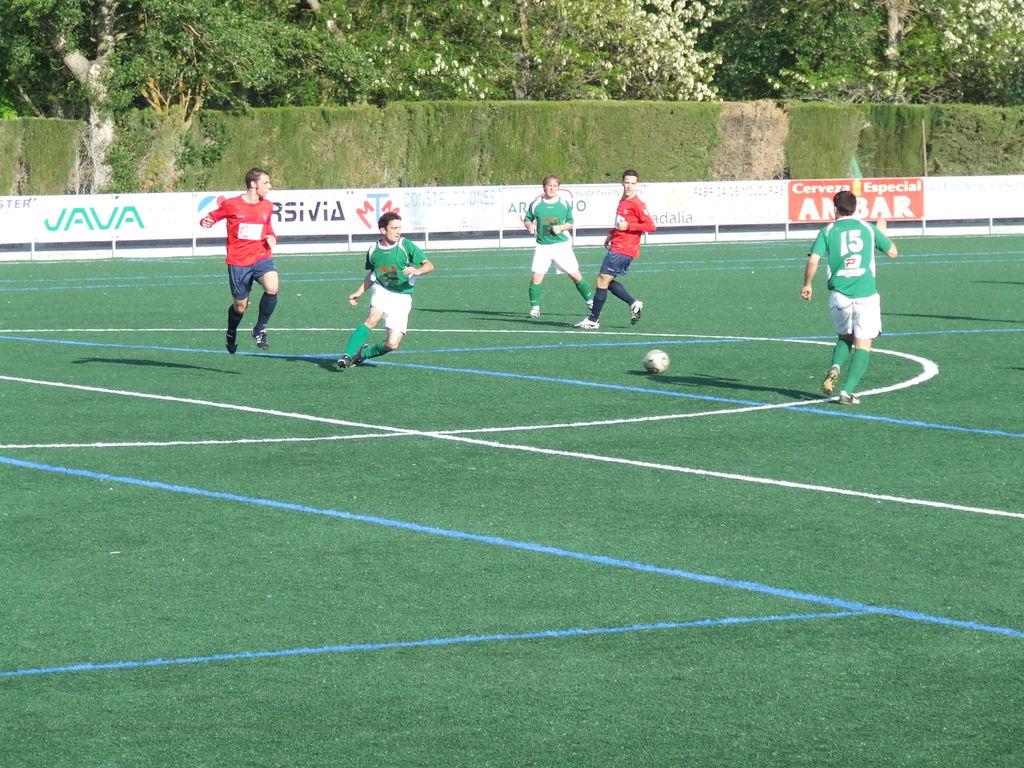What jersey number is the player on the right?
Give a very brief answer. 15. What is the leftmost sponsor on the sideboards?
Ensure brevity in your answer.  Java. 